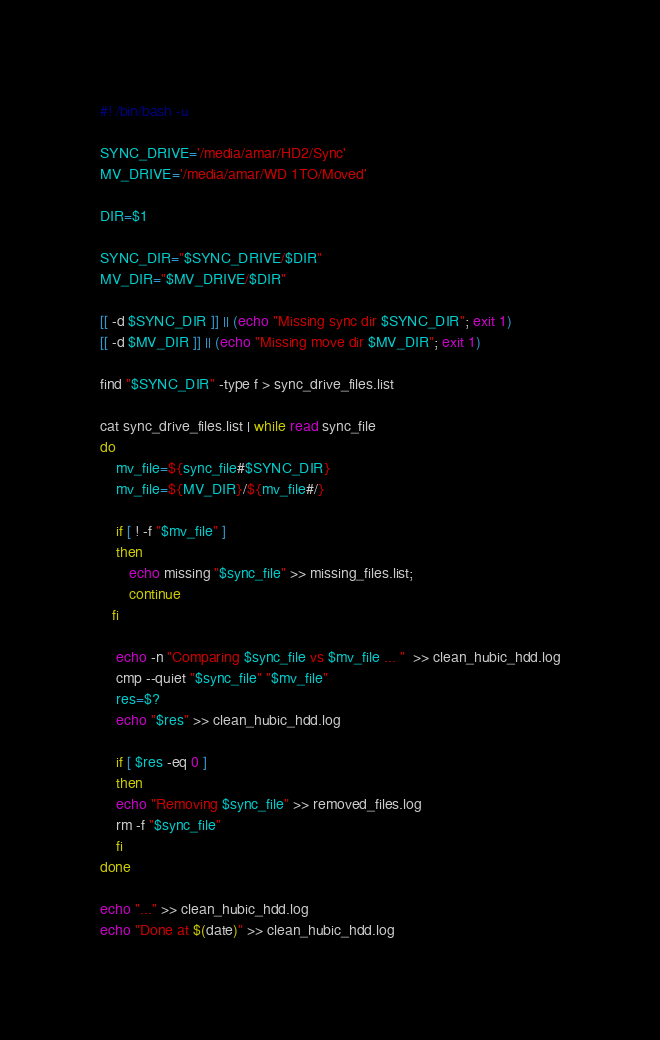<code> <loc_0><loc_0><loc_500><loc_500><_Bash_>#! /bin/bash -u

SYNC_DRIVE='/media/amar/HD2/Sync'
MV_DRIVE='/media/amar/WD 1TO/Moved'

DIR=$1

SYNC_DIR="$SYNC_DRIVE/$DIR"
MV_DIR="$MV_DRIVE/$DIR"

[[ -d $SYNC_DIR ]] || (echo "Missing sync dir $SYNC_DIR"; exit 1)
[[ -d $MV_DIR ]] || (echo "Missing move dir $MV_DIR"; exit 1)

find "$SYNC_DIR" -type f > sync_drive_files.list

cat sync_drive_files.list | while read sync_file
do
    mv_file=${sync_file#$SYNC_DIR}
    mv_file=${MV_DIR}/${mv_file#/}
    
    if [ ! -f "$mv_file" ]
    then
	   echo missing "$sync_file" >> missing_files.list; 
	   continue
   fi

    echo -n "Comparing $sync_file vs $mv_file ... "  >> clean_hubic_hdd.log
    cmp --quiet "$sync_file" "$mv_file"
    res=$?
    echo "$res" >> clean_hubic_hdd.log
    
    if [ $res -eq 0 ]
    then
	echo "Removing $sync_file" >> removed_files.log
	rm -f "$sync_file"
    fi
done

echo "..." >> clean_hubic_hdd.log
echo "Done at $(date)" >> clean_hubic_hdd.log

</code> 